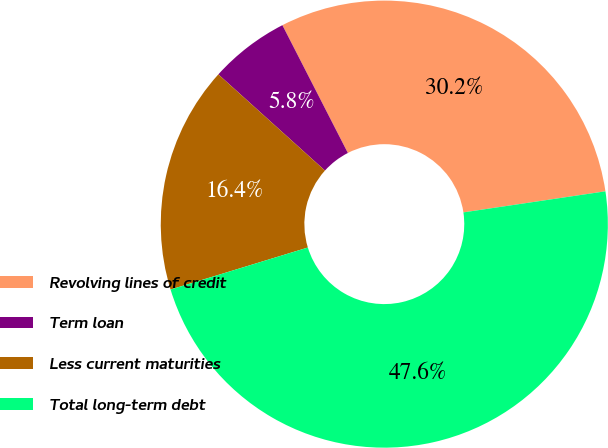Convert chart to OTSL. <chart><loc_0><loc_0><loc_500><loc_500><pie_chart><fcel>Revolving lines of credit<fcel>Term loan<fcel>Less current maturities<fcel>Total long-term debt<nl><fcel>30.19%<fcel>5.78%<fcel>16.41%<fcel>47.62%<nl></chart> 